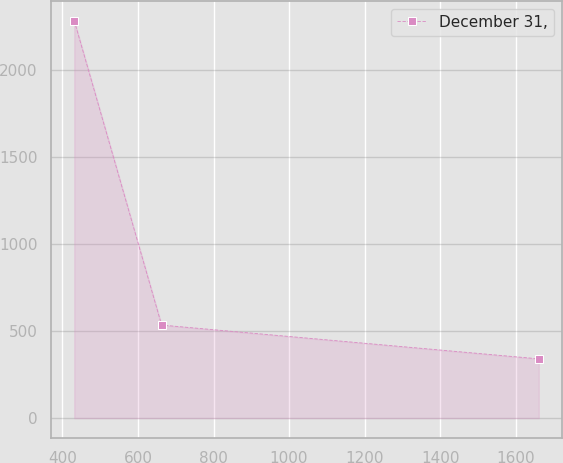Convert chart to OTSL. <chart><loc_0><loc_0><loc_500><loc_500><line_chart><ecel><fcel>December 31,<nl><fcel>431.23<fcel>2283.07<nl><fcel>662.54<fcel>534.84<nl><fcel>1661.37<fcel>340.59<nl></chart> 